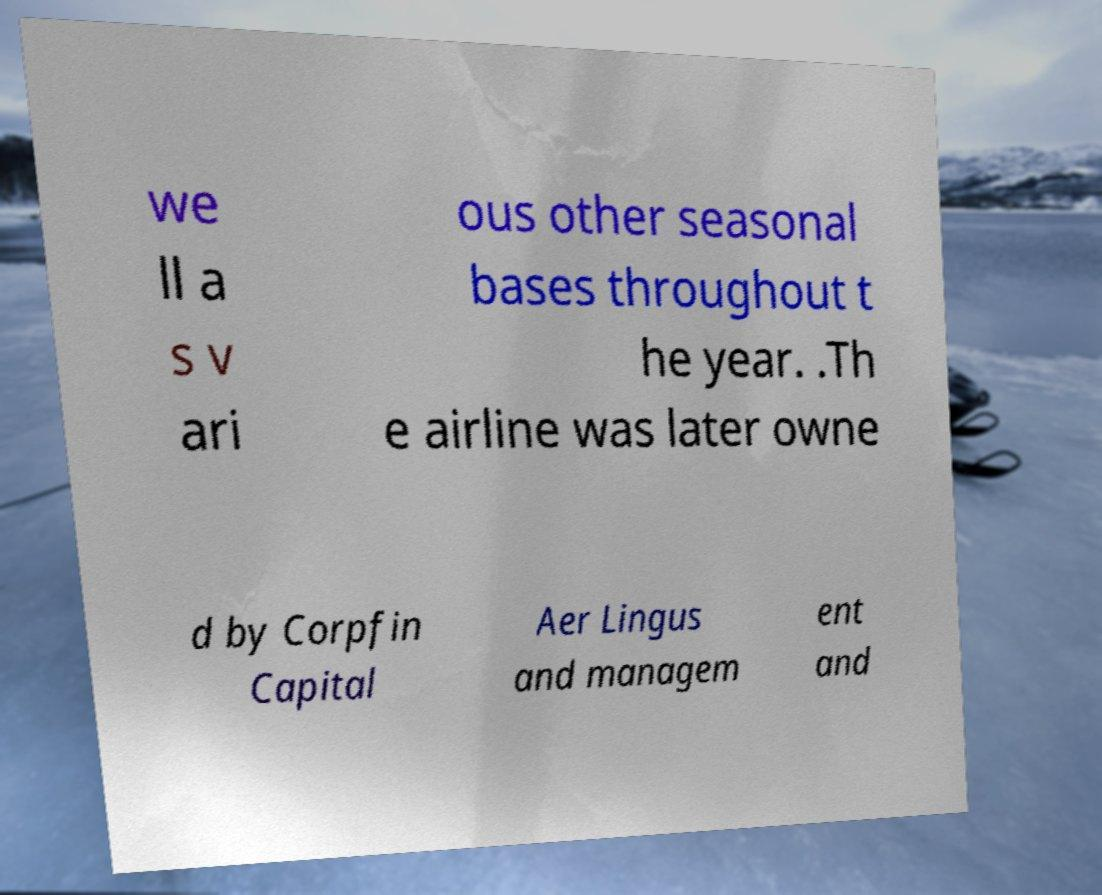Can you accurately transcribe the text from the provided image for me? we ll a s v ari ous other seasonal bases throughout t he year. .Th e airline was later owne d by Corpfin Capital Aer Lingus and managem ent and 